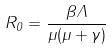Convert formula to latex. <formula><loc_0><loc_0><loc_500><loc_500>R _ { 0 } = \frac { \beta \Lambda } { \mu ( \mu + \gamma ) }</formula> 